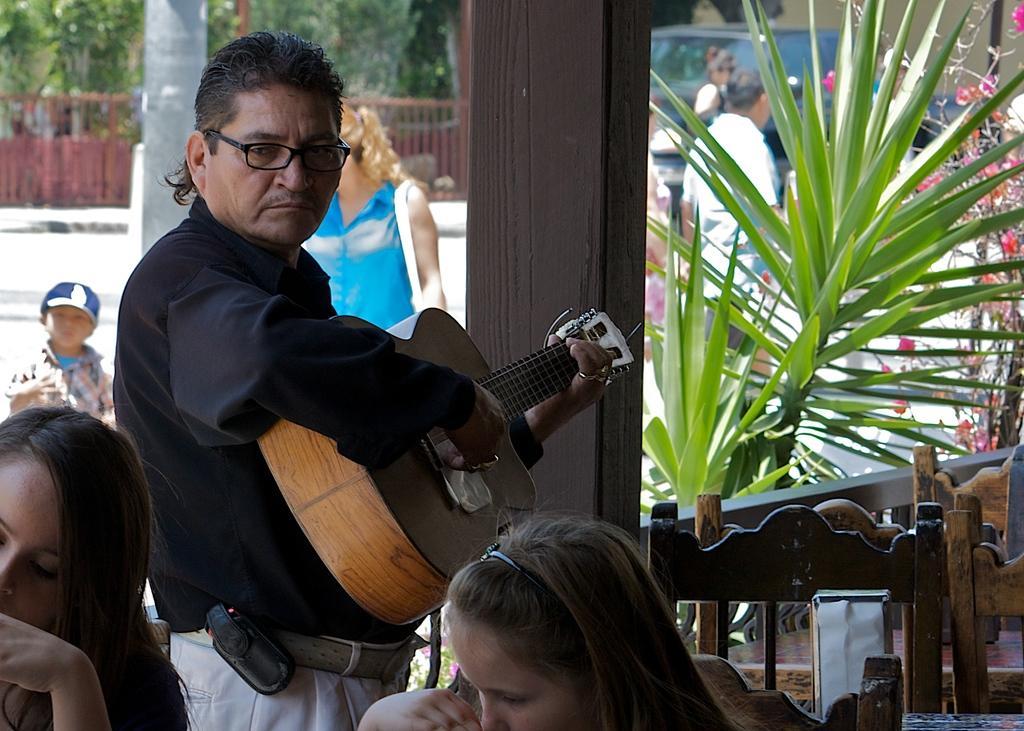Can you describe this image briefly? In this image I can see few people where one man is standing and holding a guitar, I can also see he is wearing a specs and black shirt. In the background I can see few plants, vehicles and few trees. 